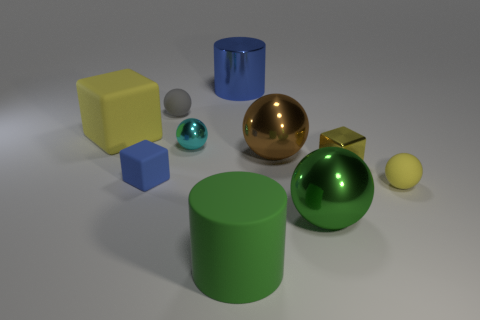Subtract all blue spheres. Subtract all purple blocks. How many spheres are left? 5 Subtract all blocks. How many objects are left? 7 Subtract 0 purple cylinders. How many objects are left? 10 Subtract all large brown rubber cubes. Subtract all cyan balls. How many objects are left? 9 Add 7 brown metallic spheres. How many brown metallic spheres are left? 8 Add 7 matte cylinders. How many matte cylinders exist? 8 